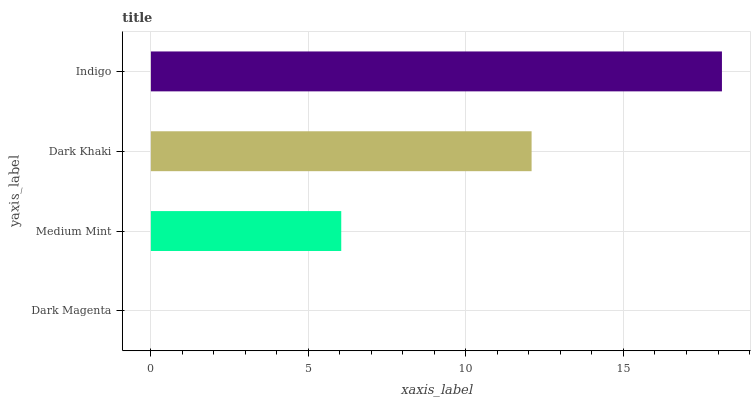Is Dark Magenta the minimum?
Answer yes or no. Yes. Is Indigo the maximum?
Answer yes or no. Yes. Is Medium Mint the minimum?
Answer yes or no. No. Is Medium Mint the maximum?
Answer yes or no. No. Is Medium Mint greater than Dark Magenta?
Answer yes or no. Yes. Is Dark Magenta less than Medium Mint?
Answer yes or no. Yes. Is Dark Magenta greater than Medium Mint?
Answer yes or no. No. Is Medium Mint less than Dark Magenta?
Answer yes or no. No. Is Dark Khaki the high median?
Answer yes or no. Yes. Is Medium Mint the low median?
Answer yes or no. Yes. Is Indigo the high median?
Answer yes or no. No. Is Dark Khaki the low median?
Answer yes or no. No. 